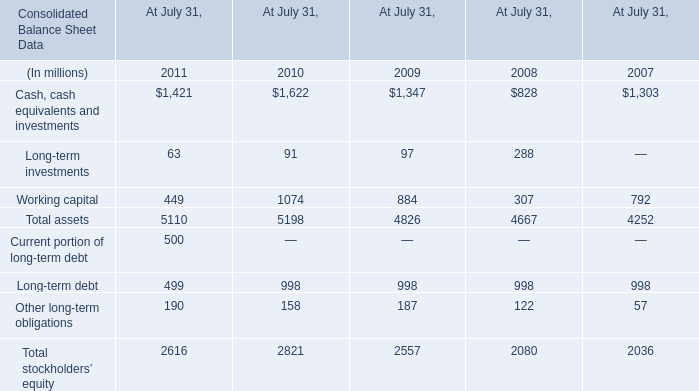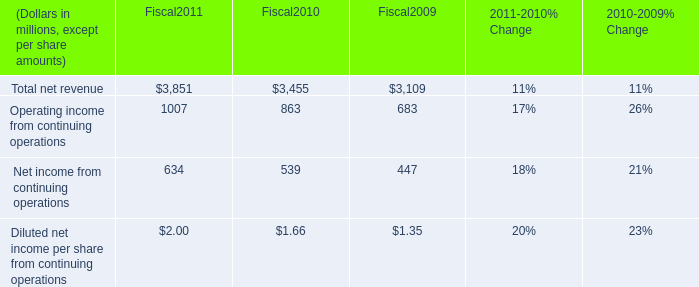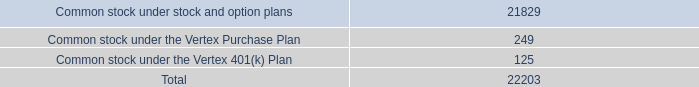What's the sum of Operating income from continuing operations of Fiscal2011, Cash, cash equivalents and investments of At July 31, 2009, and Total stockholders’ equity of At July 31, 2007 ? 
Computations: ((1007.0 + 1347.0) + 2036.0)
Answer: 4390.0. 